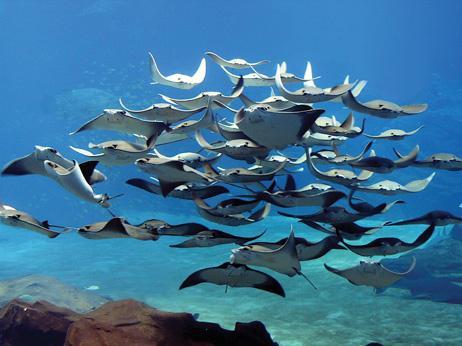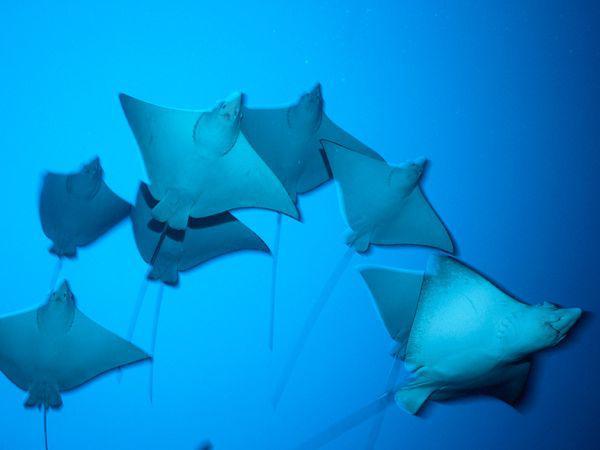The first image is the image on the left, the second image is the image on the right. For the images displayed, is the sentence "There are no more than 8 creatures in the image on the right." factually correct? Answer yes or no. Yes. The first image is the image on the left, the second image is the image on the right. Considering the images on both sides, is "There are no more than eight creatures in the image on the right." valid? Answer yes or no. Yes. 